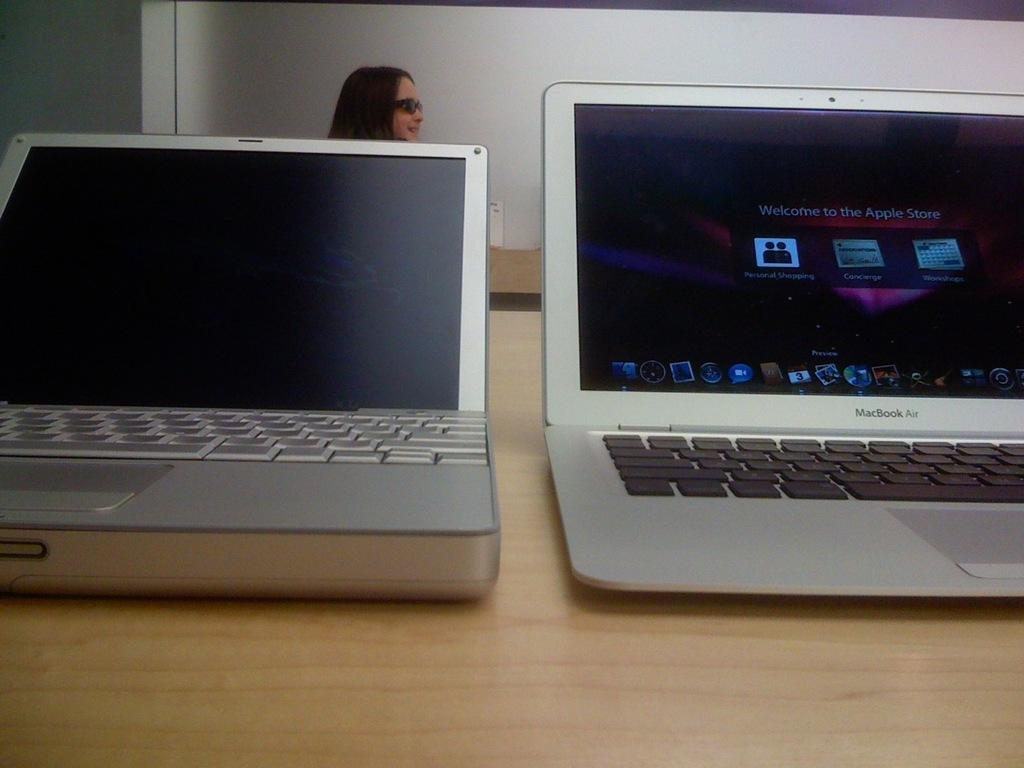<image>
Provide a brief description of the given image. Two laptops are sitting side by side with Welcome to the Apple Store displayed on the right one. 